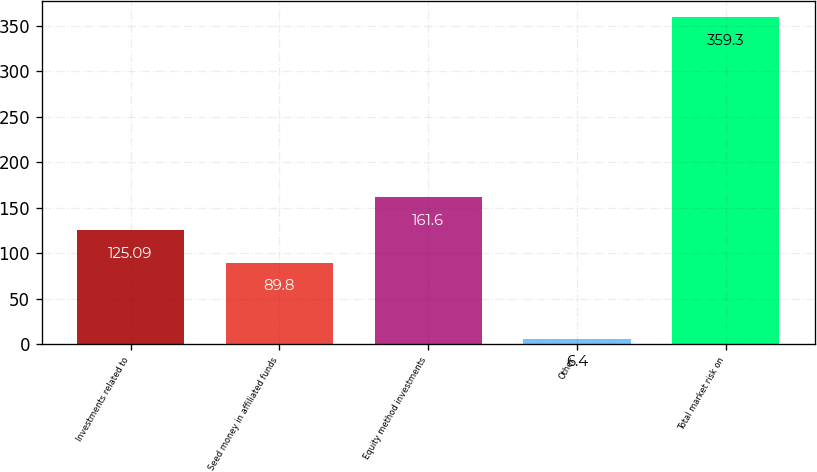Convert chart to OTSL. <chart><loc_0><loc_0><loc_500><loc_500><bar_chart><fcel>Investments related to<fcel>Seed money in affiliated funds<fcel>Equity method investments<fcel>Other<fcel>Total market risk on<nl><fcel>125.09<fcel>89.8<fcel>161.6<fcel>6.4<fcel>359.3<nl></chart> 